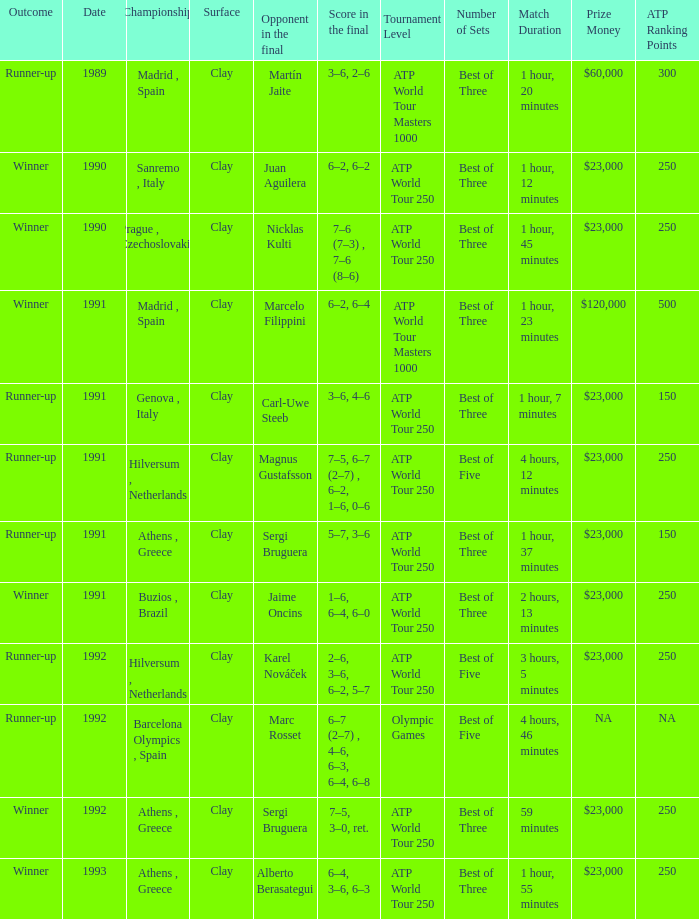What is Score In The Final, when Championship is "Athens , Greece", and when Outcome is "Winner"? 7–5, 3–0, ret., 6–4, 3–6, 6–3. 